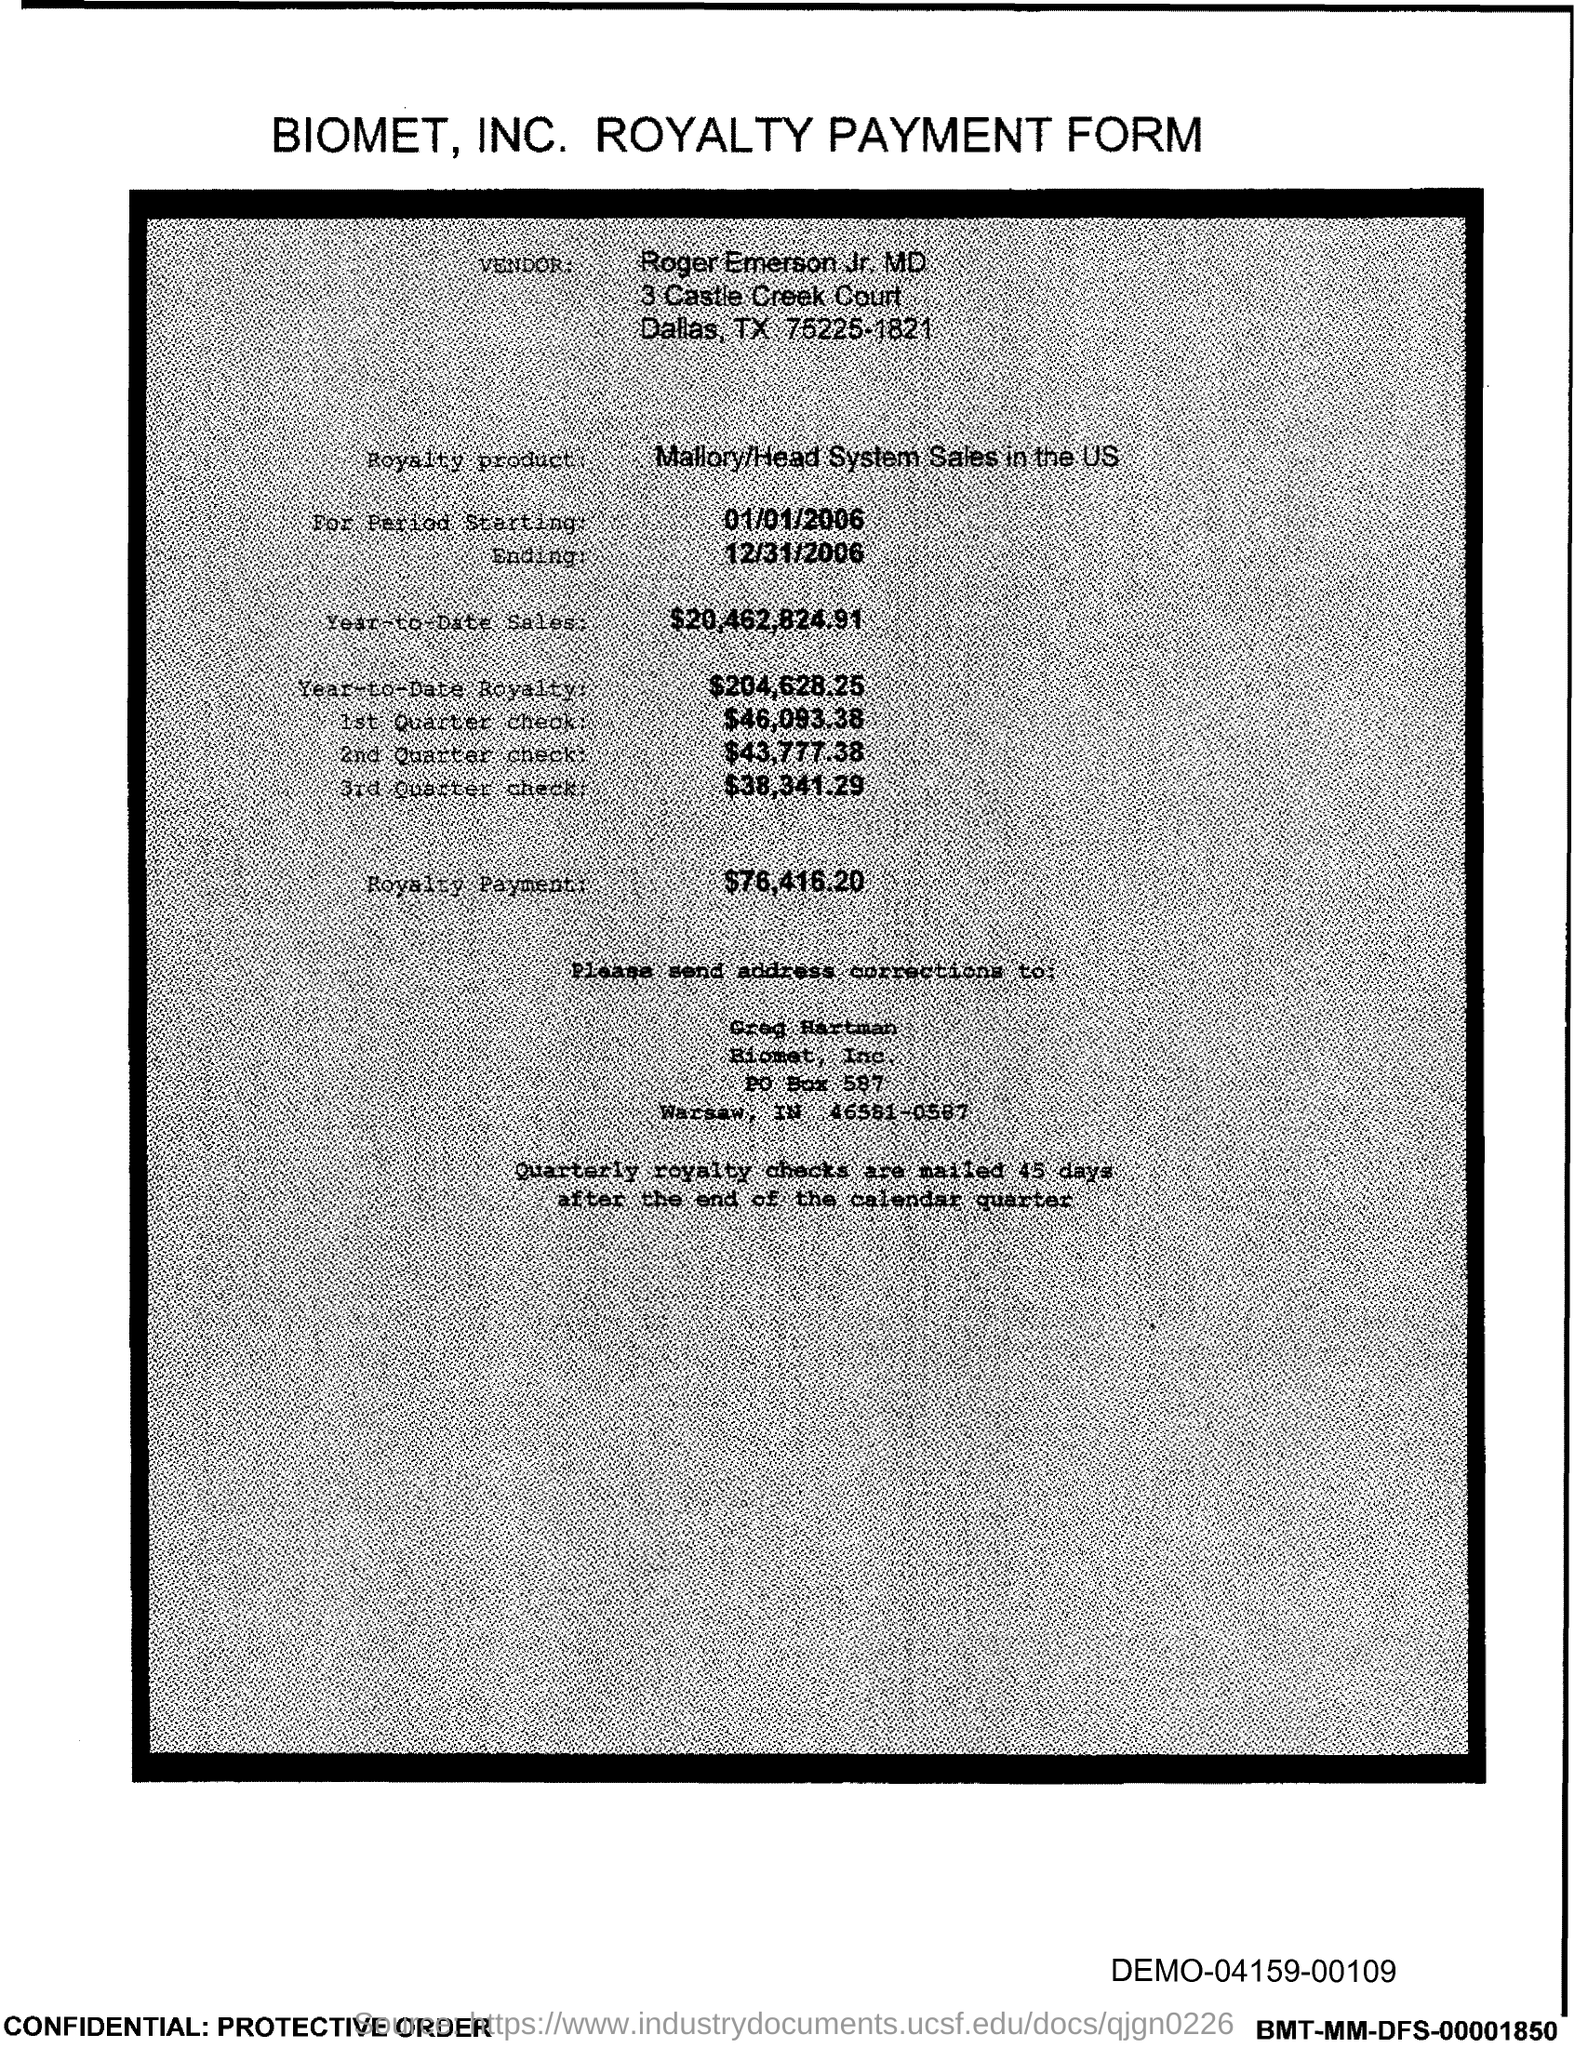What is the PO Box Number mentioned in the document?
Offer a terse response. 587. 